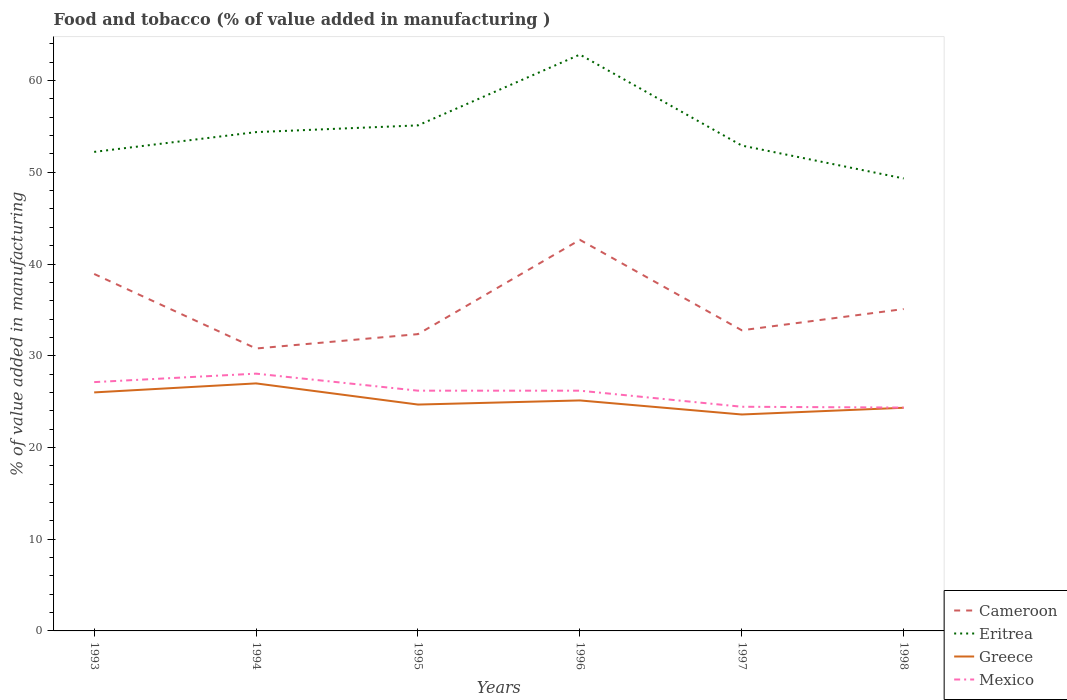How many different coloured lines are there?
Provide a succinct answer. 4. Across all years, what is the maximum value added in manufacturing food and tobacco in Mexico?
Your answer should be very brief. 24.35. What is the total value added in manufacturing food and tobacco in Greece in the graph?
Offer a very short reply. 3.39. What is the difference between the highest and the second highest value added in manufacturing food and tobacco in Greece?
Offer a very short reply. 3.39. What is the difference between the highest and the lowest value added in manufacturing food and tobacco in Greece?
Your answer should be very brief. 3. Is the value added in manufacturing food and tobacco in Eritrea strictly greater than the value added in manufacturing food and tobacco in Cameroon over the years?
Offer a terse response. No. How many lines are there?
Offer a terse response. 4. Are the values on the major ticks of Y-axis written in scientific E-notation?
Give a very brief answer. No. Does the graph contain grids?
Keep it short and to the point. No. How many legend labels are there?
Your answer should be compact. 4. What is the title of the graph?
Provide a succinct answer. Food and tobacco (% of value added in manufacturing ). What is the label or title of the Y-axis?
Make the answer very short. % of value added in manufacturing. What is the % of value added in manufacturing in Cameroon in 1993?
Offer a terse response. 38.91. What is the % of value added in manufacturing in Eritrea in 1993?
Your answer should be compact. 52.22. What is the % of value added in manufacturing of Greece in 1993?
Ensure brevity in your answer.  26. What is the % of value added in manufacturing in Mexico in 1993?
Your answer should be compact. 27.12. What is the % of value added in manufacturing of Cameroon in 1994?
Provide a short and direct response. 30.79. What is the % of value added in manufacturing of Eritrea in 1994?
Provide a short and direct response. 54.38. What is the % of value added in manufacturing in Greece in 1994?
Make the answer very short. 26.98. What is the % of value added in manufacturing in Mexico in 1994?
Provide a succinct answer. 28.05. What is the % of value added in manufacturing in Cameroon in 1995?
Provide a succinct answer. 32.36. What is the % of value added in manufacturing in Eritrea in 1995?
Keep it short and to the point. 55.11. What is the % of value added in manufacturing in Greece in 1995?
Your response must be concise. 24.68. What is the % of value added in manufacturing of Mexico in 1995?
Give a very brief answer. 26.19. What is the % of value added in manufacturing in Cameroon in 1996?
Your answer should be very brief. 42.63. What is the % of value added in manufacturing in Eritrea in 1996?
Provide a short and direct response. 62.83. What is the % of value added in manufacturing of Greece in 1996?
Provide a short and direct response. 25.13. What is the % of value added in manufacturing of Mexico in 1996?
Keep it short and to the point. 26.19. What is the % of value added in manufacturing of Cameroon in 1997?
Give a very brief answer. 32.77. What is the % of value added in manufacturing in Eritrea in 1997?
Offer a terse response. 52.91. What is the % of value added in manufacturing in Greece in 1997?
Offer a very short reply. 23.59. What is the % of value added in manufacturing of Mexico in 1997?
Provide a succinct answer. 24.44. What is the % of value added in manufacturing in Cameroon in 1998?
Provide a succinct answer. 35.09. What is the % of value added in manufacturing of Eritrea in 1998?
Give a very brief answer. 49.33. What is the % of value added in manufacturing of Greece in 1998?
Your response must be concise. 24.33. What is the % of value added in manufacturing in Mexico in 1998?
Give a very brief answer. 24.35. Across all years, what is the maximum % of value added in manufacturing in Cameroon?
Your answer should be very brief. 42.63. Across all years, what is the maximum % of value added in manufacturing of Eritrea?
Your answer should be very brief. 62.83. Across all years, what is the maximum % of value added in manufacturing of Greece?
Your answer should be very brief. 26.98. Across all years, what is the maximum % of value added in manufacturing of Mexico?
Keep it short and to the point. 28.05. Across all years, what is the minimum % of value added in manufacturing in Cameroon?
Keep it short and to the point. 30.79. Across all years, what is the minimum % of value added in manufacturing of Eritrea?
Offer a very short reply. 49.33. Across all years, what is the minimum % of value added in manufacturing in Greece?
Offer a very short reply. 23.59. Across all years, what is the minimum % of value added in manufacturing of Mexico?
Offer a very short reply. 24.35. What is the total % of value added in manufacturing in Cameroon in the graph?
Give a very brief answer. 212.56. What is the total % of value added in manufacturing of Eritrea in the graph?
Offer a terse response. 326.79. What is the total % of value added in manufacturing of Greece in the graph?
Your answer should be very brief. 150.71. What is the total % of value added in manufacturing in Mexico in the graph?
Your response must be concise. 156.34. What is the difference between the % of value added in manufacturing of Cameroon in 1993 and that in 1994?
Ensure brevity in your answer.  8.12. What is the difference between the % of value added in manufacturing of Eritrea in 1993 and that in 1994?
Offer a very short reply. -2.16. What is the difference between the % of value added in manufacturing of Greece in 1993 and that in 1994?
Offer a very short reply. -0.98. What is the difference between the % of value added in manufacturing of Mexico in 1993 and that in 1994?
Ensure brevity in your answer.  -0.92. What is the difference between the % of value added in manufacturing in Cameroon in 1993 and that in 1995?
Keep it short and to the point. 6.56. What is the difference between the % of value added in manufacturing in Eritrea in 1993 and that in 1995?
Your answer should be very brief. -2.89. What is the difference between the % of value added in manufacturing in Greece in 1993 and that in 1995?
Your answer should be very brief. 1.32. What is the difference between the % of value added in manufacturing in Mexico in 1993 and that in 1995?
Offer a very short reply. 0.93. What is the difference between the % of value added in manufacturing of Cameroon in 1993 and that in 1996?
Ensure brevity in your answer.  -3.72. What is the difference between the % of value added in manufacturing in Eritrea in 1993 and that in 1996?
Make the answer very short. -10.61. What is the difference between the % of value added in manufacturing in Greece in 1993 and that in 1996?
Your answer should be compact. 0.88. What is the difference between the % of value added in manufacturing of Mexico in 1993 and that in 1996?
Your response must be concise. 0.93. What is the difference between the % of value added in manufacturing in Cameroon in 1993 and that in 1997?
Provide a succinct answer. 6.14. What is the difference between the % of value added in manufacturing of Eritrea in 1993 and that in 1997?
Provide a short and direct response. -0.69. What is the difference between the % of value added in manufacturing of Greece in 1993 and that in 1997?
Offer a terse response. 2.41. What is the difference between the % of value added in manufacturing in Mexico in 1993 and that in 1997?
Offer a terse response. 2.69. What is the difference between the % of value added in manufacturing of Cameroon in 1993 and that in 1998?
Your answer should be very brief. 3.82. What is the difference between the % of value added in manufacturing in Eritrea in 1993 and that in 1998?
Your answer should be compact. 2.9. What is the difference between the % of value added in manufacturing in Greece in 1993 and that in 1998?
Give a very brief answer. 1.67. What is the difference between the % of value added in manufacturing in Mexico in 1993 and that in 1998?
Provide a short and direct response. 2.78. What is the difference between the % of value added in manufacturing in Cameroon in 1994 and that in 1995?
Give a very brief answer. -1.57. What is the difference between the % of value added in manufacturing of Eritrea in 1994 and that in 1995?
Make the answer very short. -0.73. What is the difference between the % of value added in manufacturing of Greece in 1994 and that in 1995?
Ensure brevity in your answer.  2.31. What is the difference between the % of value added in manufacturing in Mexico in 1994 and that in 1995?
Your answer should be very brief. 1.86. What is the difference between the % of value added in manufacturing of Cameroon in 1994 and that in 1996?
Offer a very short reply. -11.85. What is the difference between the % of value added in manufacturing of Eritrea in 1994 and that in 1996?
Make the answer very short. -8.45. What is the difference between the % of value added in manufacturing of Greece in 1994 and that in 1996?
Keep it short and to the point. 1.86. What is the difference between the % of value added in manufacturing of Mexico in 1994 and that in 1996?
Make the answer very short. 1.86. What is the difference between the % of value added in manufacturing in Cameroon in 1994 and that in 1997?
Keep it short and to the point. -1.99. What is the difference between the % of value added in manufacturing of Eritrea in 1994 and that in 1997?
Offer a terse response. 1.47. What is the difference between the % of value added in manufacturing in Greece in 1994 and that in 1997?
Provide a succinct answer. 3.39. What is the difference between the % of value added in manufacturing in Mexico in 1994 and that in 1997?
Your answer should be very brief. 3.61. What is the difference between the % of value added in manufacturing in Cameroon in 1994 and that in 1998?
Offer a terse response. -4.3. What is the difference between the % of value added in manufacturing of Eritrea in 1994 and that in 1998?
Keep it short and to the point. 5.05. What is the difference between the % of value added in manufacturing of Greece in 1994 and that in 1998?
Give a very brief answer. 2.66. What is the difference between the % of value added in manufacturing of Mexico in 1994 and that in 1998?
Give a very brief answer. 3.7. What is the difference between the % of value added in manufacturing of Cameroon in 1995 and that in 1996?
Ensure brevity in your answer.  -10.28. What is the difference between the % of value added in manufacturing of Eritrea in 1995 and that in 1996?
Your answer should be very brief. -7.72. What is the difference between the % of value added in manufacturing of Greece in 1995 and that in 1996?
Provide a succinct answer. -0.45. What is the difference between the % of value added in manufacturing of Mexico in 1995 and that in 1996?
Offer a terse response. 0. What is the difference between the % of value added in manufacturing of Cameroon in 1995 and that in 1997?
Your response must be concise. -0.42. What is the difference between the % of value added in manufacturing in Eritrea in 1995 and that in 1997?
Offer a very short reply. 2.2. What is the difference between the % of value added in manufacturing in Greece in 1995 and that in 1997?
Provide a short and direct response. 1.08. What is the difference between the % of value added in manufacturing in Mexico in 1995 and that in 1997?
Ensure brevity in your answer.  1.75. What is the difference between the % of value added in manufacturing of Cameroon in 1995 and that in 1998?
Provide a succinct answer. -2.74. What is the difference between the % of value added in manufacturing in Eritrea in 1995 and that in 1998?
Make the answer very short. 5.79. What is the difference between the % of value added in manufacturing in Greece in 1995 and that in 1998?
Your answer should be very brief. 0.35. What is the difference between the % of value added in manufacturing in Mexico in 1995 and that in 1998?
Make the answer very short. 1.84. What is the difference between the % of value added in manufacturing of Cameroon in 1996 and that in 1997?
Offer a terse response. 9.86. What is the difference between the % of value added in manufacturing in Eritrea in 1996 and that in 1997?
Your answer should be compact. 9.92. What is the difference between the % of value added in manufacturing in Greece in 1996 and that in 1997?
Your response must be concise. 1.53. What is the difference between the % of value added in manufacturing in Mexico in 1996 and that in 1997?
Provide a short and direct response. 1.75. What is the difference between the % of value added in manufacturing in Cameroon in 1996 and that in 1998?
Your response must be concise. 7.54. What is the difference between the % of value added in manufacturing in Eritrea in 1996 and that in 1998?
Your response must be concise. 13.5. What is the difference between the % of value added in manufacturing in Greece in 1996 and that in 1998?
Make the answer very short. 0.8. What is the difference between the % of value added in manufacturing of Mexico in 1996 and that in 1998?
Your answer should be very brief. 1.84. What is the difference between the % of value added in manufacturing in Cameroon in 1997 and that in 1998?
Provide a succinct answer. -2.32. What is the difference between the % of value added in manufacturing in Eritrea in 1997 and that in 1998?
Provide a short and direct response. 3.58. What is the difference between the % of value added in manufacturing in Greece in 1997 and that in 1998?
Offer a very short reply. -0.73. What is the difference between the % of value added in manufacturing of Mexico in 1997 and that in 1998?
Make the answer very short. 0.09. What is the difference between the % of value added in manufacturing in Cameroon in 1993 and the % of value added in manufacturing in Eritrea in 1994?
Provide a short and direct response. -15.47. What is the difference between the % of value added in manufacturing in Cameroon in 1993 and the % of value added in manufacturing in Greece in 1994?
Provide a short and direct response. 11.93. What is the difference between the % of value added in manufacturing of Cameroon in 1993 and the % of value added in manufacturing of Mexico in 1994?
Provide a short and direct response. 10.87. What is the difference between the % of value added in manufacturing in Eritrea in 1993 and the % of value added in manufacturing in Greece in 1994?
Provide a succinct answer. 25.24. What is the difference between the % of value added in manufacturing of Eritrea in 1993 and the % of value added in manufacturing of Mexico in 1994?
Offer a terse response. 24.18. What is the difference between the % of value added in manufacturing in Greece in 1993 and the % of value added in manufacturing in Mexico in 1994?
Make the answer very short. -2.05. What is the difference between the % of value added in manufacturing of Cameroon in 1993 and the % of value added in manufacturing of Eritrea in 1995?
Give a very brief answer. -16.2. What is the difference between the % of value added in manufacturing in Cameroon in 1993 and the % of value added in manufacturing in Greece in 1995?
Provide a short and direct response. 14.24. What is the difference between the % of value added in manufacturing of Cameroon in 1993 and the % of value added in manufacturing of Mexico in 1995?
Offer a very short reply. 12.72. What is the difference between the % of value added in manufacturing of Eritrea in 1993 and the % of value added in manufacturing of Greece in 1995?
Provide a succinct answer. 27.55. What is the difference between the % of value added in manufacturing in Eritrea in 1993 and the % of value added in manufacturing in Mexico in 1995?
Offer a very short reply. 26.03. What is the difference between the % of value added in manufacturing in Greece in 1993 and the % of value added in manufacturing in Mexico in 1995?
Offer a very short reply. -0.19. What is the difference between the % of value added in manufacturing in Cameroon in 1993 and the % of value added in manufacturing in Eritrea in 1996?
Keep it short and to the point. -23.92. What is the difference between the % of value added in manufacturing in Cameroon in 1993 and the % of value added in manufacturing in Greece in 1996?
Ensure brevity in your answer.  13.79. What is the difference between the % of value added in manufacturing of Cameroon in 1993 and the % of value added in manufacturing of Mexico in 1996?
Make the answer very short. 12.72. What is the difference between the % of value added in manufacturing of Eritrea in 1993 and the % of value added in manufacturing of Greece in 1996?
Your answer should be compact. 27.1. What is the difference between the % of value added in manufacturing in Eritrea in 1993 and the % of value added in manufacturing in Mexico in 1996?
Your response must be concise. 26.03. What is the difference between the % of value added in manufacturing in Greece in 1993 and the % of value added in manufacturing in Mexico in 1996?
Keep it short and to the point. -0.19. What is the difference between the % of value added in manufacturing of Cameroon in 1993 and the % of value added in manufacturing of Eritrea in 1997?
Your response must be concise. -14. What is the difference between the % of value added in manufacturing of Cameroon in 1993 and the % of value added in manufacturing of Greece in 1997?
Make the answer very short. 15.32. What is the difference between the % of value added in manufacturing in Cameroon in 1993 and the % of value added in manufacturing in Mexico in 1997?
Offer a terse response. 14.48. What is the difference between the % of value added in manufacturing of Eritrea in 1993 and the % of value added in manufacturing of Greece in 1997?
Your answer should be compact. 28.63. What is the difference between the % of value added in manufacturing of Eritrea in 1993 and the % of value added in manufacturing of Mexico in 1997?
Your response must be concise. 27.78. What is the difference between the % of value added in manufacturing in Greece in 1993 and the % of value added in manufacturing in Mexico in 1997?
Make the answer very short. 1.56. What is the difference between the % of value added in manufacturing in Cameroon in 1993 and the % of value added in manufacturing in Eritrea in 1998?
Offer a very short reply. -10.41. What is the difference between the % of value added in manufacturing in Cameroon in 1993 and the % of value added in manufacturing in Greece in 1998?
Your answer should be compact. 14.59. What is the difference between the % of value added in manufacturing in Cameroon in 1993 and the % of value added in manufacturing in Mexico in 1998?
Your answer should be very brief. 14.57. What is the difference between the % of value added in manufacturing in Eritrea in 1993 and the % of value added in manufacturing in Greece in 1998?
Provide a succinct answer. 27.89. What is the difference between the % of value added in manufacturing of Eritrea in 1993 and the % of value added in manufacturing of Mexico in 1998?
Your answer should be very brief. 27.88. What is the difference between the % of value added in manufacturing of Greece in 1993 and the % of value added in manufacturing of Mexico in 1998?
Ensure brevity in your answer.  1.65. What is the difference between the % of value added in manufacturing of Cameroon in 1994 and the % of value added in manufacturing of Eritrea in 1995?
Offer a terse response. -24.32. What is the difference between the % of value added in manufacturing in Cameroon in 1994 and the % of value added in manufacturing in Greece in 1995?
Provide a succinct answer. 6.11. What is the difference between the % of value added in manufacturing in Cameroon in 1994 and the % of value added in manufacturing in Mexico in 1995?
Provide a short and direct response. 4.6. What is the difference between the % of value added in manufacturing of Eritrea in 1994 and the % of value added in manufacturing of Greece in 1995?
Provide a short and direct response. 29.7. What is the difference between the % of value added in manufacturing in Eritrea in 1994 and the % of value added in manufacturing in Mexico in 1995?
Give a very brief answer. 28.19. What is the difference between the % of value added in manufacturing in Greece in 1994 and the % of value added in manufacturing in Mexico in 1995?
Provide a succinct answer. 0.79. What is the difference between the % of value added in manufacturing in Cameroon in 1994 and the % of value added in manufacturing in Eritrea in 1996?
Offer a terse response. -32.04. What is the difference between the % of value added in manufacturing in Cameroon in 1994 and the % of value added in manufacturing in Greece in 1996?
Provide a succinct answer. 5.66. What is the difference between the % of value added in manufacturing of Cameroon in 1994 and the % of value added in manufacturing of Mexico in 1996?
Offer a terse response. 4.6. What is the difference between the % of value added in manufacturing of Eritrea in 1994 and the % of value added in manufacturing of Greece in 1996?
Keep it short and to the point. 29.25. What is the difference between the % of value added in manufacturing in Eritrea in 1994 and the % of value added in manufacturing in Mexico in 1996?
Your answer should be very brief. 28.19. What is the difference between the % of value added in manufacturing in Greece in 1994 and the % of value added in manufacturing in Mexico in 1996?
Offer a very short reply. 0.79. What is the difference between the % of value added in manufacturing of Cameroon in 1994 and the % of value added in manufacturing of Eritrea in 1997?
Your answer should be compact. -22.12. What is the difference between the % of value added in manufacturing in Cameroon in 1994 and the % of value added in manufacturing in Greece in 1997?
Make the answer very short. 7.19. What is the difference between the % of value added in manufacturing in Cameroon in 1994 and the % of value added in manufacturing in Mexico in 1997?
Provide a short and direct response. 6.35. What is the difference between the % of value added in manufacturing in Eritrea in 1994 and the % of value added in manufacturing in Greece in 1997?
Offer a very short reply. 30.79. What is the difference between the % of value added in manufacturing of Eritrea in 1994 and the % of value added in manufacturing of Mexico in 1997?
Offer a very short reply. 29.94. What is the difference between the % of value added in manufacturing of Greece in 1994 and the % of value added in manufacturing of Mexico in 1997?
Offer a terse response. 2.55. What is the difference between the % of value added in manufacturing of Cameroon in 1994 and the % of value added in manufacturing of Eritrea in 1998?
Your answer should be compact. -18.54. What is the difference between the % of value added in manufacturing of Cameroon in 1994 and the % of value added in manufacturing of Greece in 1998?
Provide a short and direct response. 6.46. What is the difference between the % of value added in manufacturing of Cameroon in 1994 and the % of value added in manufacturing of Mexico in 1998?
Provide a succinct answer. 6.44. What is the difference between the % of value added in manufacturing in Eritrea in 1994 and the % of value added in manufacturing in Greece in 1998?
Give a very brief answer. 30.05. What is the difference between the % of value added in manufacturing in Eritrea in 1994 and the % of value added in manufacturing in Mexico in 1998?
Your response must be concise. 30.03. What is the difference between the % of value added in manufacturing in Greece in 1994 and the % of value added in manufacturing in Mexico in 1998?
Your response must be concise. 2.64. What is the difference between the % of value added in manufacturing in Cameroon in 1995 and the % of value added in manufacturing in Eritrea in 1996?
Keep it short and to the point. -30.48. What is the difference between the % of value added in manufacturing of Cameroon in 1995 and the % of value added in manufacturing of Greece in 1996?
Provide a short and direct response. 7.23. What is the difference between the % of value added in manufacturing in Cameroon in 1995 and the % of value added in manufacturing in Mexico in 1996?
Provide a succinct answer. 6.17. What is the difference between the % of value added in manufacturing of Eritrea in 1995 and the % of value added in manufacturing of Greece in 1996?
Keep it short and to the point. 29.99. What is the difference between the % of value added in manufacturing in Eritrea in 1995 and the % of value added in manufacturing in Mexico in 1996?
Your response must be concise. 28.92. What is the difference between the % of value added in manufacturing in Greece in 1995 and the % of value added in manufacturing in Mexico in 1996?
Ensure brevity in your answer.  -1.51. What is the difference between the % of value added in manufacturing of Cameroon in 1995 and the % of value added in manufacturing of Eritrea in 1997?
Your answer should be compact. -20.56. What is the difference between the % of value added in manufacturing in Cameroon in 1995 and the % of value added in manufacturing in Greece in 1997?
Make the answer very short. 8.76. What is the difference between the % of value added in manufacturing in Cameroon in 1995 and the % of value added in manufacturing in Mexico in 1997?
Make the answer very short. 7.92. What is the difference between the % of value added in manufacturing in Eritrea in 1995 and the % of value added in manufacturing in Greece in 1997?
Provide a short and direct response. 31.52. What is the difference between the % of value added in manufacturing in Eritrea in 1995 and the % of value added in manufacturing in Mexico in 1997?
Your answer should be very brief. 30.67. What is the difference between the % of value added in manufacturing in Greece in 1995 and the % of value added in manufacturing in Mexico in 1997?
Give a very brief answer. 0.24. What is the difference between the % of value added in manufacturing of Cameroon in 1995 and the % of value added in manufacturing of Eritrea in 1998?
Offer a terse response. -16.97. What is the difference between the % of value added in manufacturing in Cameroon in 1995 and the % of value added in manufacturing in Greece in 1998?
Your answer should be compact. 8.03. What is the difference between the % of value added in manufacturing in Cameroon in 1995 and the % of value added in manufacturing in Mexico in 1998?
Give a very brief answer. 8.01. What is the difference between the % of value added in manufacturing in Eritrea in 1995 and the % of value added in manufacturing in Greece in 1998?
Ensure brevity in your answer.  30.78. What is the difference between the % of value added in manufacturing in Eritrea in 1995 and the % of value added in manufacturing in Mexico in 1998?
Offer a terse response. 30.77. What is the difference between the % of value added in manufacturing in Greece in 1995 and the % of value added in manufacturing in Mexico in 1998?
Offer a terse response. 0.33. What is the difference between the % of value added in manufacturing in Cameroon in 1996 and the % of value added in manufacturing in Eritrea in 1997?
Give a very brief answer. -10.28. What is the difference between the % of value added in manufacturing in Cameroon in 1996 and the % of value added in manufacturing in Greece in 1997?
Your answer should be very brief. 19.04. What is the difference between the % of value added in manufacturing of Cameroon in 1996 and the % of value added in manufacturing of Mexico in 1997?
Your response must be concise. 18.2. What is the difference between the % of value added in manufacturing of Eritrea in 1996 and the % of value added in manufacturing of Greece in 1997?
Your answer should be compact. 39.24. What is the difference between the % of value added in manufacturing of Eritrea in 1996 and the % of value added in manufacturing of Mexico in 1997?
Keep it short and to the point. 38.39. What is the difference between the % of value added in manufacturing of Greece in 1996 and the % of value added in manufacturing of Mexico in 1997?
Your response must be concise. 0.69. What is the difference between the % of value added in manufacturing in Cameroon in 1996 and the % of value added in manufacturing in Eritrea in 1998?
Provide a short and direct response. -6.69. What is the difference between the % of value added in manufacturing in Cameroon in 1996 and the % of value added in manufacturing in Greece in 1998?
Make the answer very short. 18.31. What is the difference between the % of value added in manufacturing of Cameroon in 1996 and the % of value added in manufacturing of Mexico in 1998?
Offer a terse response. 18.29. What is the difference between the % of value added in manufacturing in Eritrea in 1996 and the % of value added in manufacturing in Greece in 1998?
Ensure brevity in your answer.  38.5. What is the difference between the % of value added in manufacturing of Eritrea in 1996 and the % of value added in manufacturing of Mexico in 1998?
Offer a terse response. 38.48. What is the difference between the % of value added in manufacturing of Greece in 1996 and the % of value added in manufacturing of Mexico in 1998?
Your answer should be very brief. 0.78. What is the difference between the % of value added in manufacturing in Cameroon in 1997 and the % of value added in manufacturing in Eritrea in 1998?
Offer a very short reply. -16.55. What is the difference between the % of value added in manufacturing of Cameroon in 1997 and the % of value added in manufacturing of Greece in 1998?
Offer a terse response. 8.45. What is the difference between the % of value added in manufacturing in Cameroon in 1997 and the % of value added in manufacturing in Mexico in 1998?
Offer a terse response. 8.43. What is the difference between the % of value added in manufacturing in Eritrea in 1997 and the % of value added in manufacturing in Greece in 1998?
Keep it short and to the point. 28.58. What is the difference between the % of value added in manufacturing in Eritrea in 1997 and the % of value added in manufacturing in Mexico in 1998?
Offer a terse response. 28.56. What is the difference between the % of value added in manufacturing in Greece in 1997 and the % of value added in manufacturing in Mexico in 1998?
Ensure brevity in your answer.  -0.75. What is the average % of value added in manufacturing in Cameroon per year?
Keep it short and to the point. 35.43. What is the average % of value added in manufacturing in Eritrea per year?
Keep it short and to the point. 54.46. What is the average % of value added in manufacturing in Greece per year?
Your response must be concise. 25.12. What is the average % of value added in manufacturing in Mexico per year?
Offer a very short reply. 26.06. In the year 1993, what is the difference between the % of value added in manufacturing in Cameroon and % of value added in manufacturing in Eritrea?
Provide a succinct answer. -13.31. In the year 1993, what is the difference between the % of value added in manufacturing of Cameroon and % of value added in manufacturing of Greece?
Offer a very short reply. 12.91. In the year 1993, what is the difference between the % of value added in manufacturing of Cameroon and % of value added in manufacturing of Mexico?
Offer a very short reply. 11.79. In the year 1993, what is the difference between the % of value added in manufacturing of Eritrea and % of value added in manufacturing of Greece?
Offer a very short reply. 26.22. In the year 1993, what is the difference between the % of value added in manufacturing of Eritrea and % of value added in manufacturing of Mexico?
Your answer should be very brief. 25.1. In the year 1993, what is the difference between the % of value added in manufacturing of Greece and % of value added in manufacturing of Mexico?
Ensure brevity in your answer.  -1.12. In the year 1994, what is the difference between the % of value added in manufacturing in Cameroon and % of value added in manufacturing in Eritrea?
Give a very brief answer. -23.59. In the year 1994, what is the difference between the % of value added in manufacturing of Cameroon and % of value added in manufacturing of Greece?
Make the answer very short. 3.8. In the year 1994, what is the difference between the % of value added in manufacturing of Cameroon and % of value added in manufacturing of Mexico?
Ensure brevity in your answer.  2.74. In the year 1994, what is the difference between the % of value added in manufacturing of Eritrea and % of value added in manufacturing of Greece?
Ensure brevity in your answer.  27.4. In the year 1994, what is the difference between the % of value added in manufacturing in Eritrea and % of value added in manufacturing in Mexico?
Provide a succinct answer. 26.33. In the year 1994, what is the difference between the % of value added in manufacturing of Greece and % of value added in manufacturing of Mexico?
Provide a succinct answer. -1.06. In the year 1995, what is the difference between the % of value added in manufacturing of Cameroon and % of value added in manufacturing of Eritrea?
Offer a very short reply. -22.76. In the year 1995, what is the difference between the % of value added in manufacturing in Cameroon and % of value added in manufacturing in Greece?
Offer a terse response. 7.68. In the year 1995, what is the difference between the % of value added in manufacturing of Cameroon and % of value added in manufacturing of Mexico?
Ensure brevity in your answer.  6.16. In the year 1995, what is the difference between the % of value added in manufacturing of Eritrea and % of value added in manufacturing of Greece?
Your answer should be compact. 30.44. In the year 1995, what is the difference between the % of value added in manufacturing of Eritrea and % of value added in manufacturing of Mexico?
Offer a very short reply. 28.92. In the year 1995, what is the difference between the % of value added in manufacturing in Greece and % of value added in manufacturing in Mexico?
Your answer should be very brief. -1.51. In the year 1996, what is the difference between the % of value added in manufacturing in Cameroon and % of value added in manufacturing in Eritrea?
Give a very brief answer. -20.2. In the year 1996, what is the difference between the % of value added in manufacturing in Cameroon and % of value added in manufacturing in Greece?
Keep it short and to the point. 17.51. In the year 1996, what is the difference between the % of value added in manufacturing in Cameroon and % of value added in manufacturing in Mexico?
Your answer should be compact. 16.44. In the year 1996, what is the difference between the % of value added in manufacturing of Eritrea and % of value added in manufacturing of Greece?
Offer a terse response. 37.71. In the year 1996, what is the difference between the % of value added in manufacturing of Eritrea and % of value added in manufacturing of Mexico?
Provide a short and direct response. 36.64. In the year 1996, what is the difference between the % of value added in manufacturing of Greece and % of value added in manufacturing of Mexico?
Make the answer very short. -1.06. In the year 1997, what is the difference between the % of value added in manufacturing of Cameroon and % of value added in manufacturing of Eritrea?
Offer a very short reply. -20.14. In the year 1997, what is the difference between the % of value added in manufacturing of Cameroon and % of value added in manufacturing of Greece?
Offer a very short reply. 9.18. In the year 1997, what is the difference between the % of value added in manufacturing in Cameroon and % of value added in manufacturing in Mexico?
Ensure brevity in your answer.  8.34. In the year 1997, what is the difference between the % of value added in manufacturing in Eritrea and % of value added in manufacturing in Greece?
Provide a succinct answer. 29.32. In the year 1997, what is the difference between the % of value added in manufacturing of Eritrea and % of value added in manufacturing of Mexico?
Your response must be concise. 28.47. In the year 1997, what is the difference between the % of value added in manufacturing in Greece and % of value added in manufacturing in Mexico?
Offer a very short reply. -0.84. In the year 1998, what is the difference between the % of value added in manufacturing in Cameroon and % of value added in manufacturing in Eritrea?
Your answer should be compact. -14.24. In the year 1998, what is the difference between the % of value added in manufacturing of Cameroon and % of value added in manufacturing of Greece?
Offer a terse response. 10.76. In the year 1998, what is the difference between the % of value added in manufacturing in Cameroon and % of value added in manufacturing in Mexico?
Keep it short and to the point. 10.74. In the year 1998, what is the difference between the % of value added in manufacturing in Eritrea and % of value added in manufacturing in Greece?
Provide a short and direct response. 25. In the year 1998, what is the difference between the % of value added in manufacturing in Eritrea and % of value added in manufacturing in Mexico?
Ensure brevity in your answer.  24.98. In the year 1998, what is the difference between the % of value added in manufacturing in Greece and % of value added in manufacturing in Mexico?
Give a very brief answer. -0.02. What is the ratio of the % of value added in manufacturing of Cameroon in 1993 to that in 1994?
Your response must be concise. 1.26. What is the ratio of the % of value added in manufacturing in Eritrea in 1993 to that in 1994?
Your answer should be compact. 0.96. What is the ratio of the % of value added in manufacturing of Greece in 1993 to that in 1994?
Keep it short and to the point. 0.96. What is the ratio of the % of value added in manufacturing in Mexico in 1993 to that in 1994?
Offer a very short reply. 0.97. What is the ratio of the % of value added in manufacturing of Cameroon in 1993 to that in 1995?
Offer a very short reply. 1.2. What is the ratio of the % of value added in manufacturing of Eritrea in 1993 to that in 1995?
Provide a succinct answer. 0.95. What is the ratio of the % of value added in manufacturing of Greece in 1993 to that in 1995?
Provide a short and direct response. 1.05. What is the ratio of the % of value added in manufacturing of Mexico in 1993 to that in 1995?
Your response must be concise. 1.04. What is the ratio of the % of value added in manufacturing in Cameroon in 1993 to that in 1996?
Your answer should be very brief. 0.91. What is the ratio of the % of value added in manufacturing in Eritrea in 1993 to that in 1996?
Your answer should be compact. 0.83. What is the ratio of the % of value added in manufacturing in Greece in 1993 to that in 1996?
Make the answer very short. 1.03. What is the ratio of the % of value added in manufacturing of Mexico in 1993 to that in 1996?
Give a very brief answer. 1.04. What is the ratio of the % of value added in manufacturing in Cameroon in 1993 to that in 1997?
Ensure brevity in your answer.  1.19. What is the ratio of the % of value added in manufacturing of Eritrea in 1993 to that in 1997?
Ensure brevity in your answer.  0.99. What is the ratio of the % of value added in manufacturing of Greece in 1993 to that in 1997?
Your answer should be very brief. 1.1. What is the ratio of the % of value added in manufacturing of Mexico in 1993 to that in 1997?
Offer a very short reply. 1.11. What is the ratio of the % of value added in manufacturing of Cameroon in 1993 to that in 1998?
Keep it short and to the point. 1.11. What is the ratio of the % of value added in manufacturing of Eritrea in 1993 to that in 1998?
Offer a very short reply. 1.06. What is the ratio of the % of value added in manufacturing in Greece in 1993 to that in 1998?
Your answer should be compact. 1.07. What is the ratio of the % of value added in manufacturing of Mexico in 1993 to that in 1998?
Keep it short and to the point. 1.11. What is the ratio of the % of value added in manufacturing of Cameroon in 1994 to that in 1995?
Keep it short and to the point. 0.95. What is the ratio of the % of value added in manufacturing of Eritrea in 1994 to that in 1995?
Make the answer very short. 0.99. What is the ratio of the % of value added in manufacturing in Greece in 1994 to that in 1995?
Your answer should be very brief. 1.09. What is the ratio of the % of value added in manufacturing of Mexico in 1994 to that in 1995?
Keep it short and to the point. 1.07. What is the ratio of the % of value added in manufacturing of Cameroon in 1994 to that in 1996?
Ensure brevity in your answer.  0.72. What is the ratio of the % of value added in manufacturing in Eritrea in 1994 to that in 1996?
Your answer should be compact. 0.87. What is the ratio of the % of value added in manufacturing of Greece in 1994 to that in 1996?
Offer a very short reply. 1.07. What is the ratio of the % of value added in manufacturing of Mexico in 1994 to that in 1996?
Offer a terse response. 1.07. What is the ratio of the % of value added in manufacturing in Cameroon in 1994 to that in 1997?
Offer a very short reply. 0.94. What is the ratio of the % of value added in manufacturing of Eritrea in 1994 to that in 1997?
Your answer should be compact. 1.03. What is the ratio of the % of value added in manufacturing of Greece in 1994 to that in 1997?
Give a very brief answer. 1.14. What is the ratio of the % of value added in manufacturing in Mexico in 1994 to that in 1997?
Your response must be concise. 1.15. What is the ratio of the % of value added in manufacturing in Cameroon in 1994 to that in 1998?
Keep it short and to the point. 0.88. What is the ratio of the % of value added in manufacturing of Eritrea in 1994 to that in 1998?
Make the answer very short. 1.1. What is the ratio of the % of value added in manufacturing in Greece in 1994 to that in 1998?
Offer a very short reply. 1.11. What is the ratio of the % of value added in manufacturing in Mexico in 1994 to that in 1998?
Give a very brief answer. 1.15. What is the ratio of the % of value added in manufacturing of Cameroon in 1995 to that in 1996?
Offer a terse response. 0.76. What is the ratio of the % of value added in manufacturing in Eritrea in 1995 to that in 1996?
Your answer should be very brief. 0.88. What is the ratio of the % of value added in manufacturing of Greece in 1995 to that in 1996?
Ensure brevity in your answer.  0.98. What is the ratio of the % of value added in manufacturing of Cameroon in 1995 to that in 1997?
Provide a succinct answer. 0.99. What is the ratio of the % of value added in manufacturing of Eritrea in 1995 to that in 1997?
Give a very brief answer. 1.04. What is the ratio of the % of value added in manufacturing of Greece in 1995 to that in 1997?
Give a very brief answer. 1.05. What is the ratio of the % of value added in manufacturing of Mexico in 1995 to that in 1997?
Your answer should be compact. 1.07. What is the ratio of the % of value added in manufacturing in Cameroon in 1995 to that in 1998?
Give a very brief answer. 0.92. What is the ratio of the % of value added in manufacturing in Eritrea in 1995 to that in 1998?
Provide a succinct answer. 1.12. What is the ratio of the % of value added in manufacturing in Greece in 1995 to that in 1998?
Your response must be concise. 1.01. What is the ratio of the % of value added in manufacturing in Mexico in 1995 to that in 1998?
Offer a terse response. 1.08. What is the ratio of the % of value added in manufacturing of Cameroon in 1996 to that in 1997?
Ensure brevity in your answer.  1.3. What is the ratio of the % of value added in manufacturing in Eritrea in 1996 to that in 1997?
Ensure brevity in your answer.  1.19. What is the ratio of the % of value added in manufacturing of Greece in 1996 to that in 1997?
Offer a terse response. 1.06. What is the ratio of the % of value added in manufacturing in Mexico in 1996 to that in 1997?
Your answer should be very brief. 1.07. What is the ratio of the % of value added in manufacturing in Cameroon in 1996 to that in 1998?
Make the answer very short. 1.21. What is the ratio of the % of value added in manufacturing of Eritrea in 1996 to that in 1998?
Provide a succinct answer. 1.27. What is the ratio of the % of value added in manufacturing of Greece in 1996 to that in 1998?
Offer a very short reply. 1.03. What is the ratio of the % of value added in manufacturing of Mexico in 1996 to that in 1998?
Offer a terse response. 1.08. What is the ratio of the % of value added in manufacturing in Cameroon in 1997 to that in 1998?
Offer a terse response. 0.93. What is the ratio of the % of value added in manufacturing in Eritrea in 1997 to that in 1998?
Provide a short and direct response. 1.07. What is the ratio of the % of value added in manufacturing of Greece in 1997 to that in 1998?
Give a very brief answer. 0.97. What is the ratio of the % of value added in manufacturing of Mexico in 1997 to that in 1998?
Ensure brevity in your answer.  1. What is the difference between the highest and the second highest % of value added in manufacturing of Cameroon?
Ensure brevity in your answer.  3.72. What is the difference between the highest and the second highest % of value added in manufacturing of Eritrea?
Offer a very short reply. 7.72. What is the difference between the highest and the second highest % of value added in manufacturing of Greece?
Offer a terse response. 0.98. What is the difference between the highest and the second highest % of value added in manufacturing of Mexico?
Offer a terse response. 0.92. What is the difference between the highest and the lowest % of value added in manufacturing of Cameroon?
Keep it short and to the point. 11.85. What is the difference between the highest and the lowest % of value added in manufacturing of Eritrea?
Your answer should be compact. 13.5. What is the difference between the highest and the lowest % of value added in manufacturing in Greece?
Keep it short and to the point. 3.39. What is the difference between the highest and the lowest % of value added in manufacturing of Mexico?
Keep it short and to the point. 3.7. 